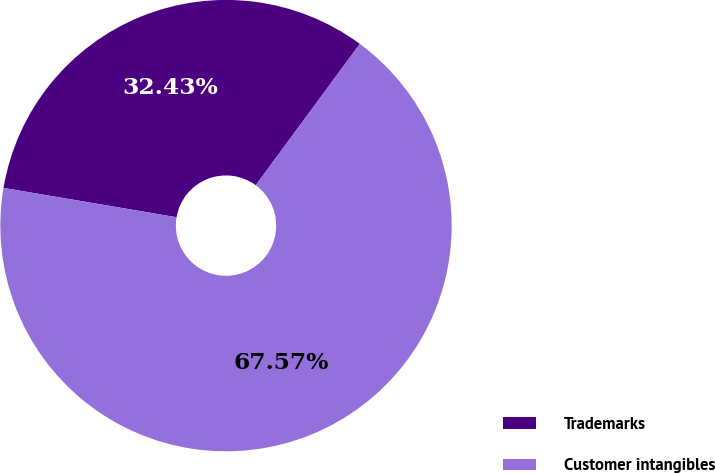<chart> <loc_0><loc_0><loc_500><loc_500><pie_chart><fcel>Trademarks<fcel>Customer intangibles<nl><fcel>32.43%<fcel>67.57%<nl></chart> 